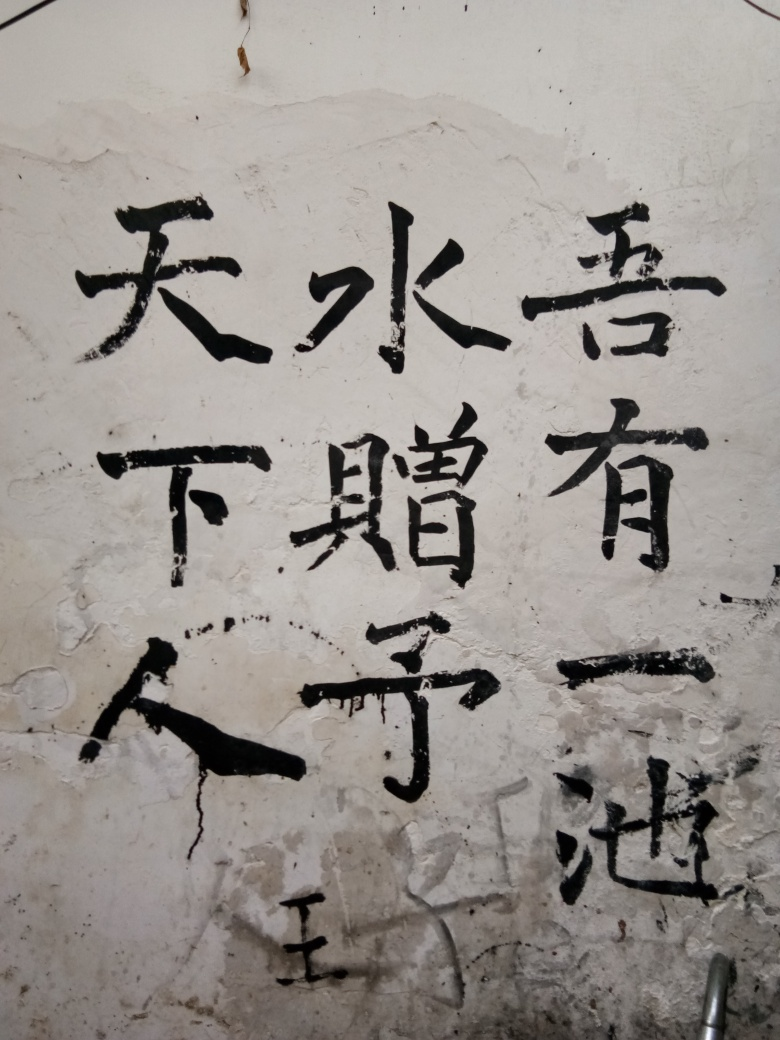Is the focus accurate? The focus appears to be accurate, capturing the Chinese characters on the wall with sufficient sharpness to distinguish individual strokes. The lighting conditions and the texture of the wall also contribute to the clarity of the image. 